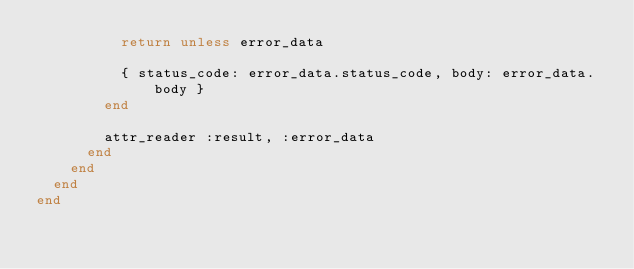<code> <loc_0><loc_0><loc_500><loc_500><_Ruby_>          return unless error_data

          { status_code: error_data.status_code, body: error_data.body }
        end

        attr_reader :result, :error_data
      end
    end
  end
end
</code> 